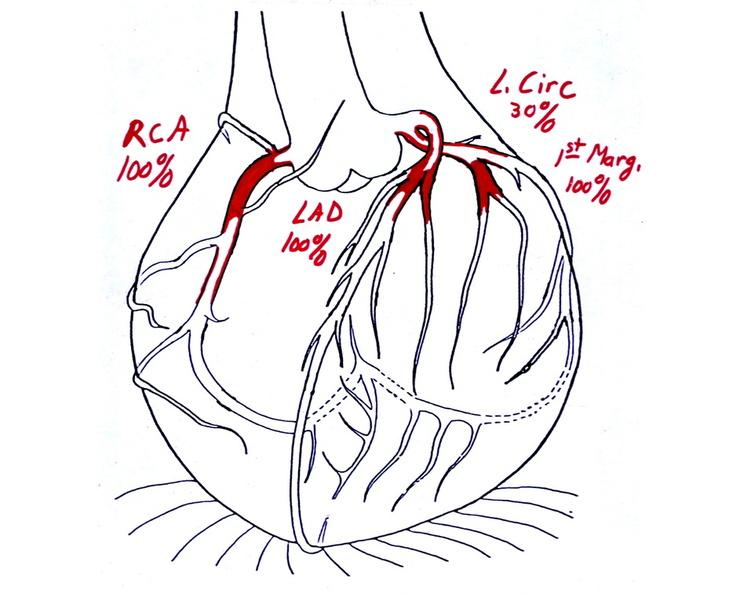does this image show coronary artery atherosclerosis diagram?
Answer the question using a single word or phrase. Yes 